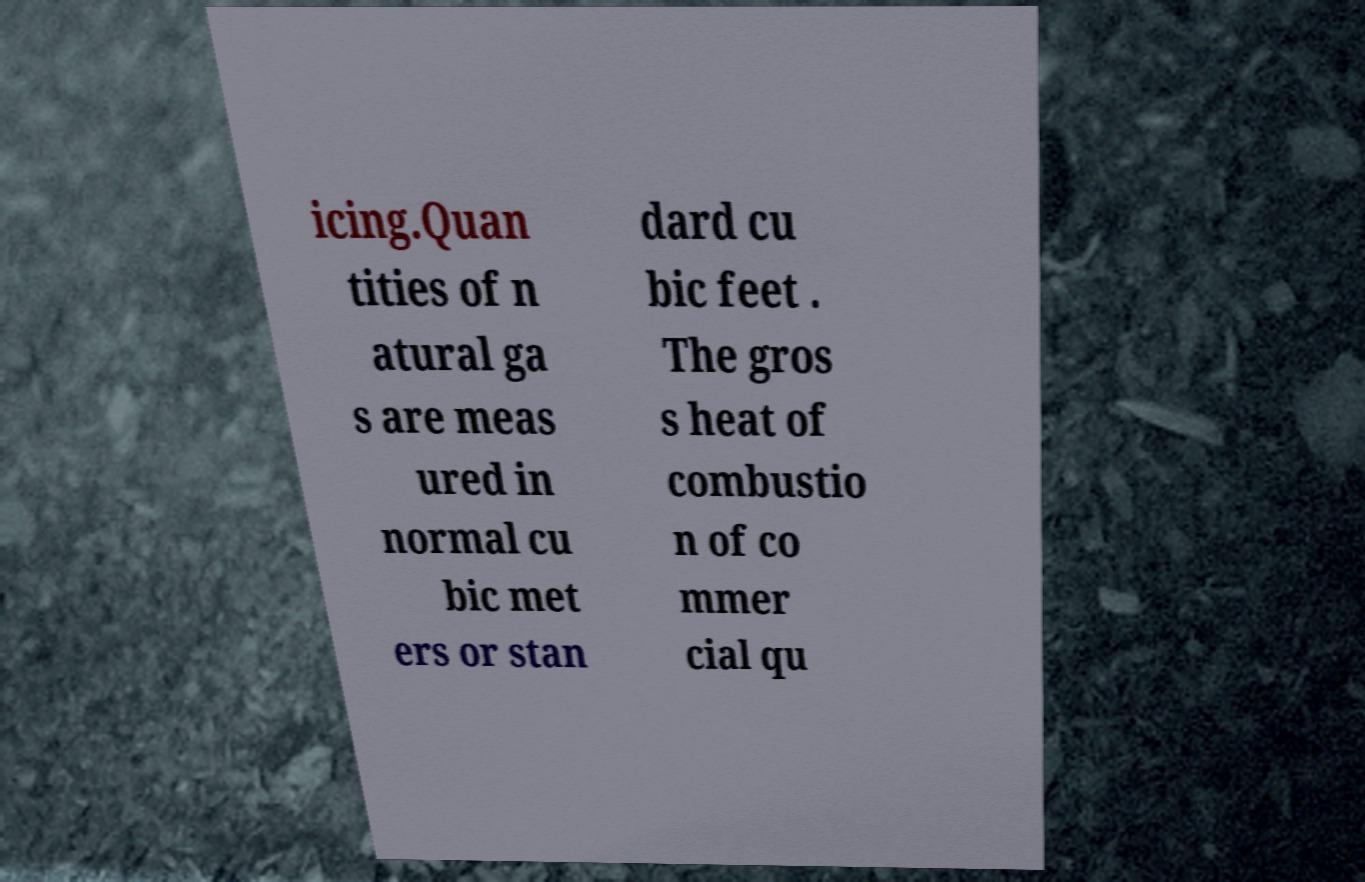For documentation purposes, I need the text within this image transcribed. Could you provide that? icing.Quan tities of n atural ga s are meas ured in normal cu bic met ers or stan dard cu bic feet . The gros s heat of combustio n of co mmer cial qu 